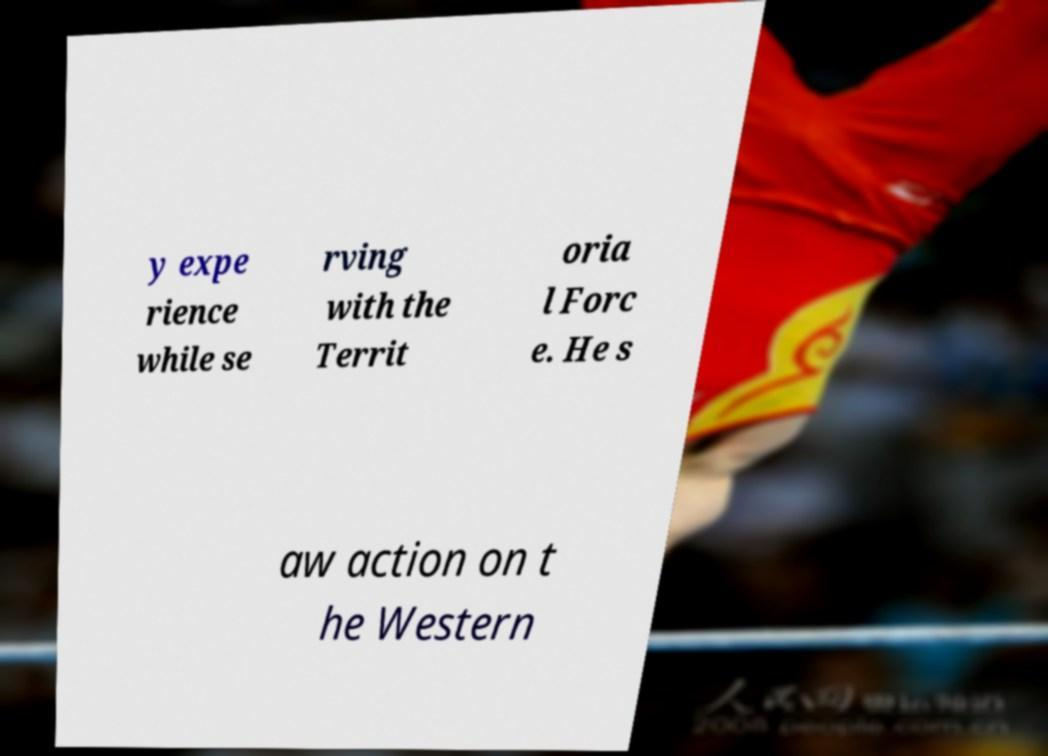Could you extract and type out the text from this image? y expe rience while se rving with the Territ oria l Forc e. He s aw action on t he Western 